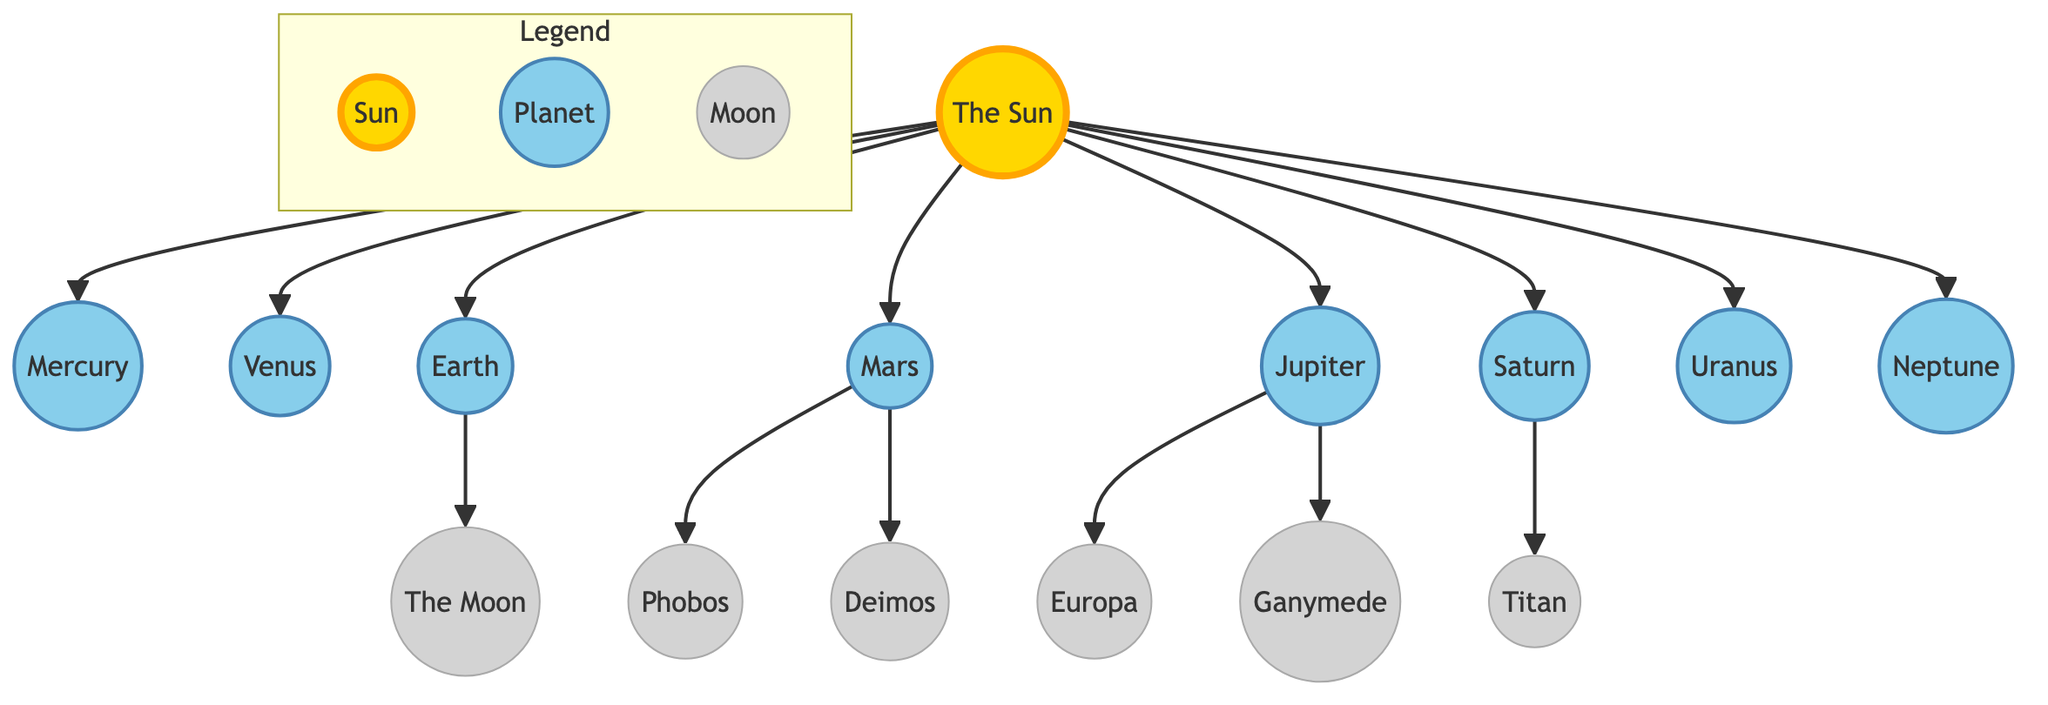What is the largest planet in the solar system? The diagram clearly shows that Jupiter has a significantly larger size representation compared to the other planets. By comparing the sizes of all the planets, it's evident that Jupiter stands out as the largest.
Answer: Jupiter How many moons are shown orbiting Mars? The diagram indicates two moons orbiting Mars, which are labeled as Phobos and Deimos. By counting these two labeled moons around Mars, we conclude there are two.
Answer: 2 Which planet is closest to the Sun? The diagram shows the planets in order from the Sun. Mercury is the first planet following the Sun's direct connection, indicating that it is the closest.
Answer: Mercury What is the color used to represent the Sun in the diagram? The diagram attributes a specific fill color to the Sun, which is distinctly yellow. This is visually confirmed in the diagram where the Sun is shown with a fill of #FFD700.
Answer: Yellow Which moon is labeled as the largest of all shown moons? The diagram indicates a labeling for Ganymede, which is a moon of Jupiter. Its size in the diagram, being attached to the larger Jupiter, suggests that Ganymede is the largest moon represented in the diagram.
Answer: Ganymede What is the relationship between Earth and the Moon in the diagram? The diagram depicts a direct connection from Earth to the Moon, illustrating that the Moon orbits around Earth. This clear relationship showcases the Moon as a satellite of Earth.
Answer: The Moon Which planet is second from the Sun? By analyzing the sequence of planets shown in the diagram, we determine that Venus follows Mercury as the second planet from the Sun. This order confirms that Venus is positioned second.
Answer: Venus What color represents the planets in the diagram? All planets in the diagram are uniformly represented with a light blue color. This consistent representation distinguishes them from the Sun and moons, focusing on the fill color #87CEEB.
Answer: Light blue 